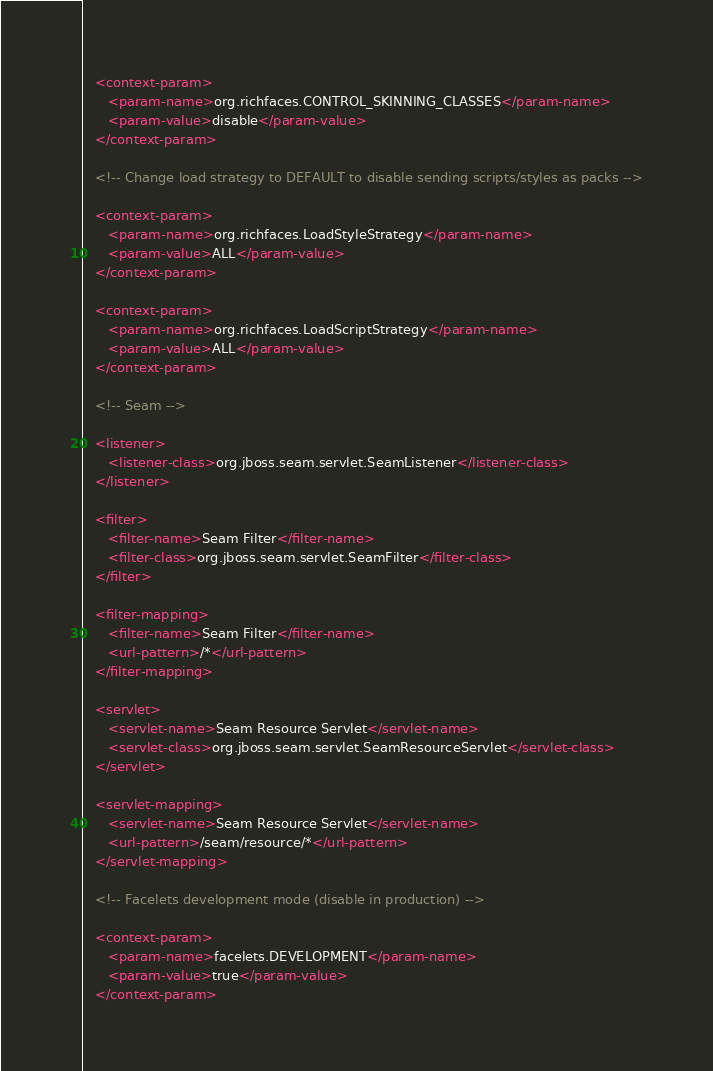<code> <loc_0><loc_0><loc_500><loc_500><_XML_>   <context-param>
      <param-name>org.richfaces.CONTROL_SKINNING_CLASSES</param-name>
      <param-value>disable</param-value>
   </context-param>

   <!-- Change load strategy to DEFAULT to disable sending scripts/styles as packs -->

   <context-param>
      <param-name>org.richfaces.LoadStyleStrategy</param-name>
      <param-value>ALL</param-value>
   </context-param>

   <context-param>
      <param-name>org.richfaces.LoadScriptStrategy</param-name>
      <param-value>ALL</param-value>
   </context-param>

   <!-- Seam -->

   <listener>
      <listener-class>org.jboss.seam.servlet.SeamListener</listener-class>
   </listener>

   <filter>
      <filter-name>Seam Filter</filter-name>
      <filter-class>org.jboss.seam.servlet.SeamFilter</filter-class>
   </filter>

   <filter-mapping>
      <filter-name>Seam Filter</filter-name>
      <url-pattern>/*</url-pattern>
   </filter-mapping>

   <servlet>
      <servlet-name>Seam Resource Servlet</servlet-name>
      <servlet-class>org.jboss.seam.servlet.SeamResourceServlet</servlet-class>
   </servlet>

   <servlet-mapping>
      <servlet-name>Seam Resource Servlet</servlet-name>
      <url-pattern>/seam/resource/*</url-pattern>
   </servlet-mapping>

   <!-- Facelets development mode (disable in production) -->

   <context-param>
      <param-name>facelets.DEVELOPMENT</param-name>
      <param-value>true</param-value>
   </context-param>
</code> 